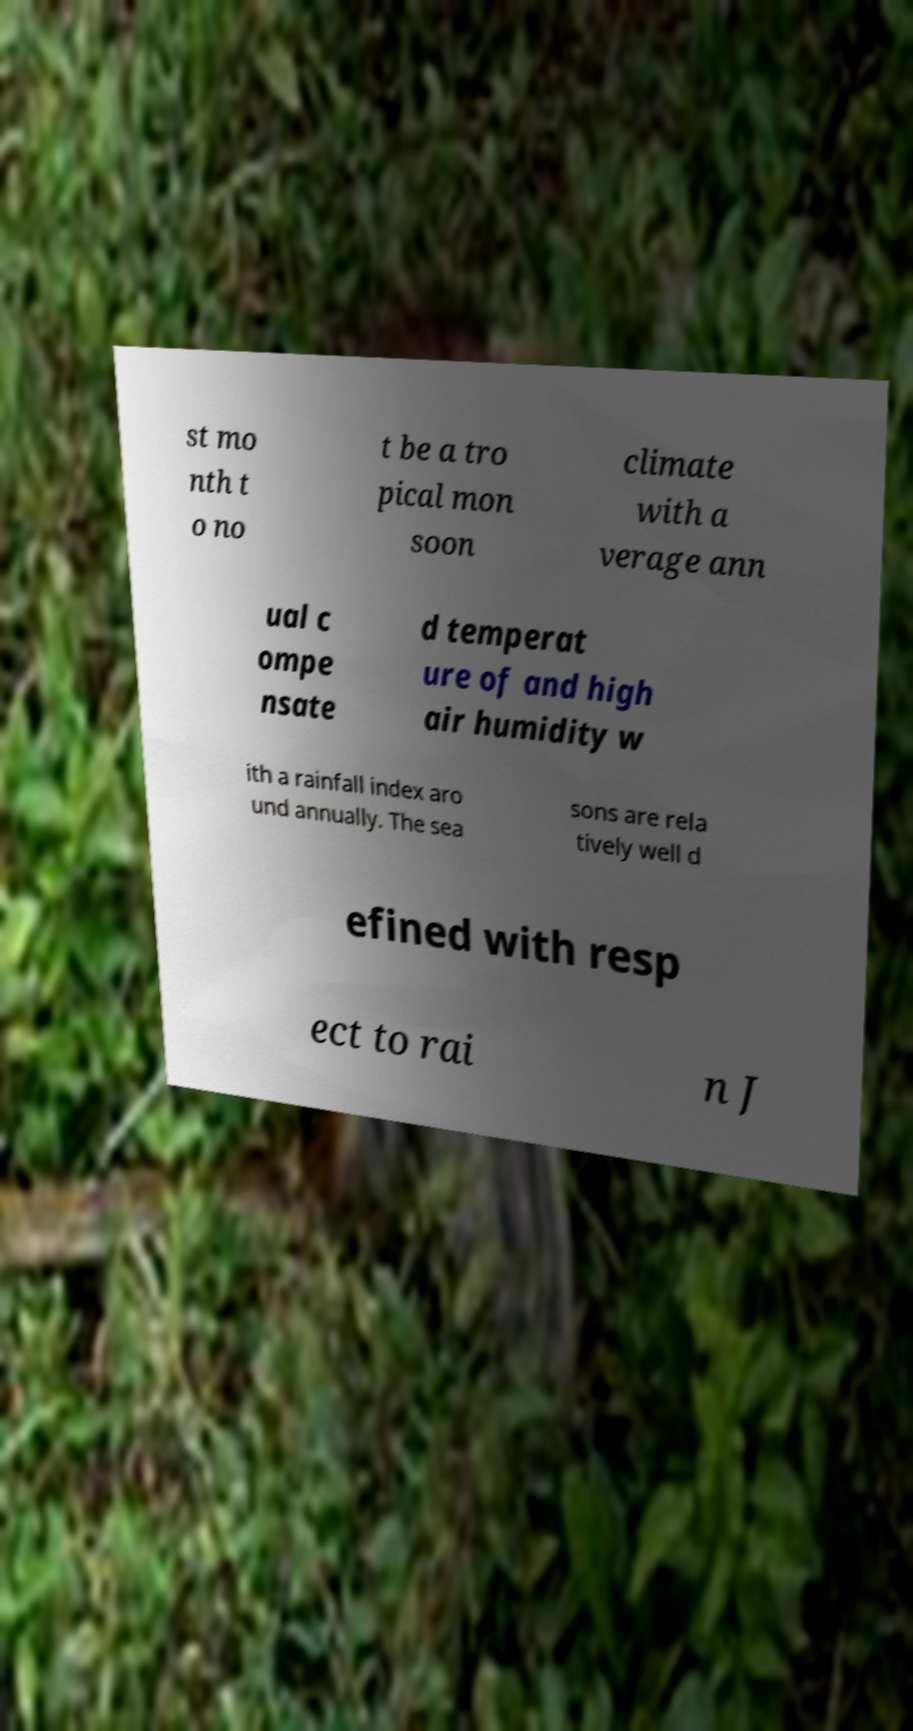I need the written content from this picture converted into text. Can you do that? st mo nth t o no t be a tro pical mon soon climate with a verage ann ual c ompe nsate d temperat ure of and high air humidity w ith a rainfall index aro und annually. The sea sons are rela tively well d efined with resp ect to rai n J 